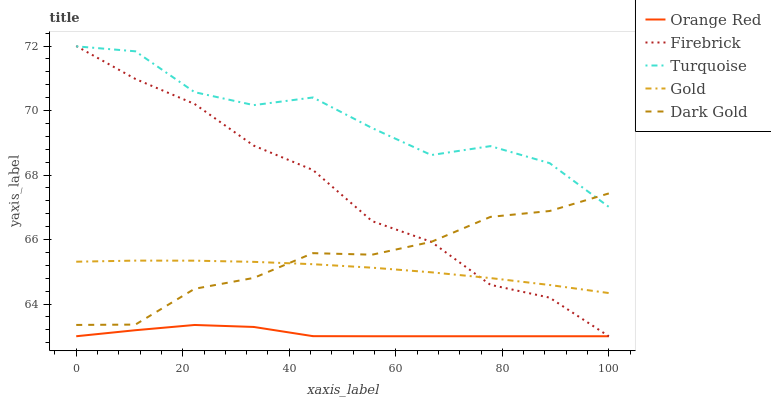Does Orange Red have the minimum area under the curve?
Answer yes or no. Yes. Does Turquoise have the maximum area under the curve?
Answer yes or no. Yes. Does Turquoise have the minimum area under the curve?
Answer yes or no. No. Does Orange Red have the maximum area under the curve?
Answer yes or no. No. Is Gold the smoothest?
Answer yes or no. Yes. Is Turquoise the roughest?
Answer yes or no. Yes. Is Orange Red the smoothest?
Answer yes or no. No. Is Orange Red the roughest?
Answer yes or no. No. Does Firebrick have the lowest value?
Answer yes or no. Yes. Does Turquoise have the lowest value?
Answer yes or no. No. Does Firebrick have the highest value?
Answer yes or no. Yes. Does Turquoise have the highest value?
Answer yes or no. No. Is Gold less than Turquoise?
Answer yes or no. Yes. Is Dark Gold greater than Orange Red?
Answer yes or no. Yes. Does Dark Gold intersect Firebrick?
Answer yes or no. Yes. Is Dark Gold less than Firebrick?
Answer yes or no. No. Is Dark Gold greater than Firebrick?
Answer yes or no. No. Does Gold intersect Turquoise?
Answer yes or no. No. 